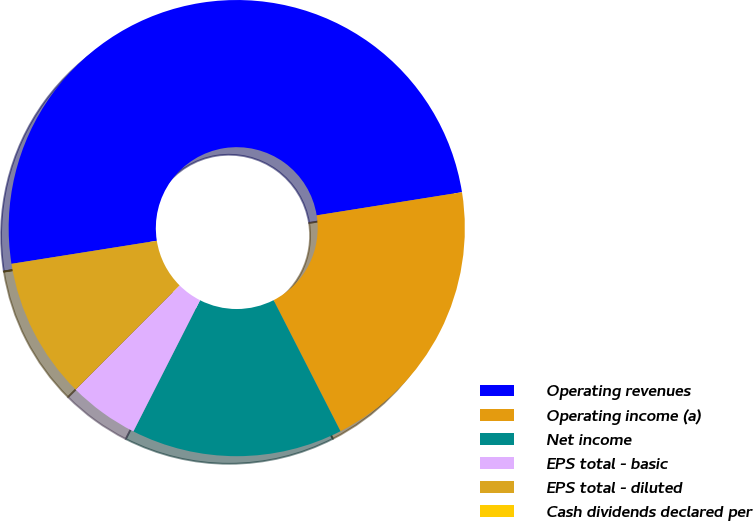Convert chart to OTSL. <chart><loc_0><loc_0><loc_500><loc_500><pie_chart><fcel>Operating revenues<fcel>Operating income (a)<fcel>Net income<fcel>EPS total - basic<fcel>EPS total - diluted<fcel>Cash dividends declared per<nl><fcel>49.99%<fcel>20.0%<fcel>15.0%<fcel>5.0%<fcel>10.0%<fcel>0.01%<nl></chart> 